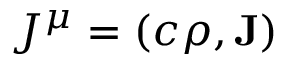Convert formula to latex. <formula><loc_0><loc_0><loc_500><loc_500>J ^ { \mu } = \left ( c \rho , J \right )</formula> 